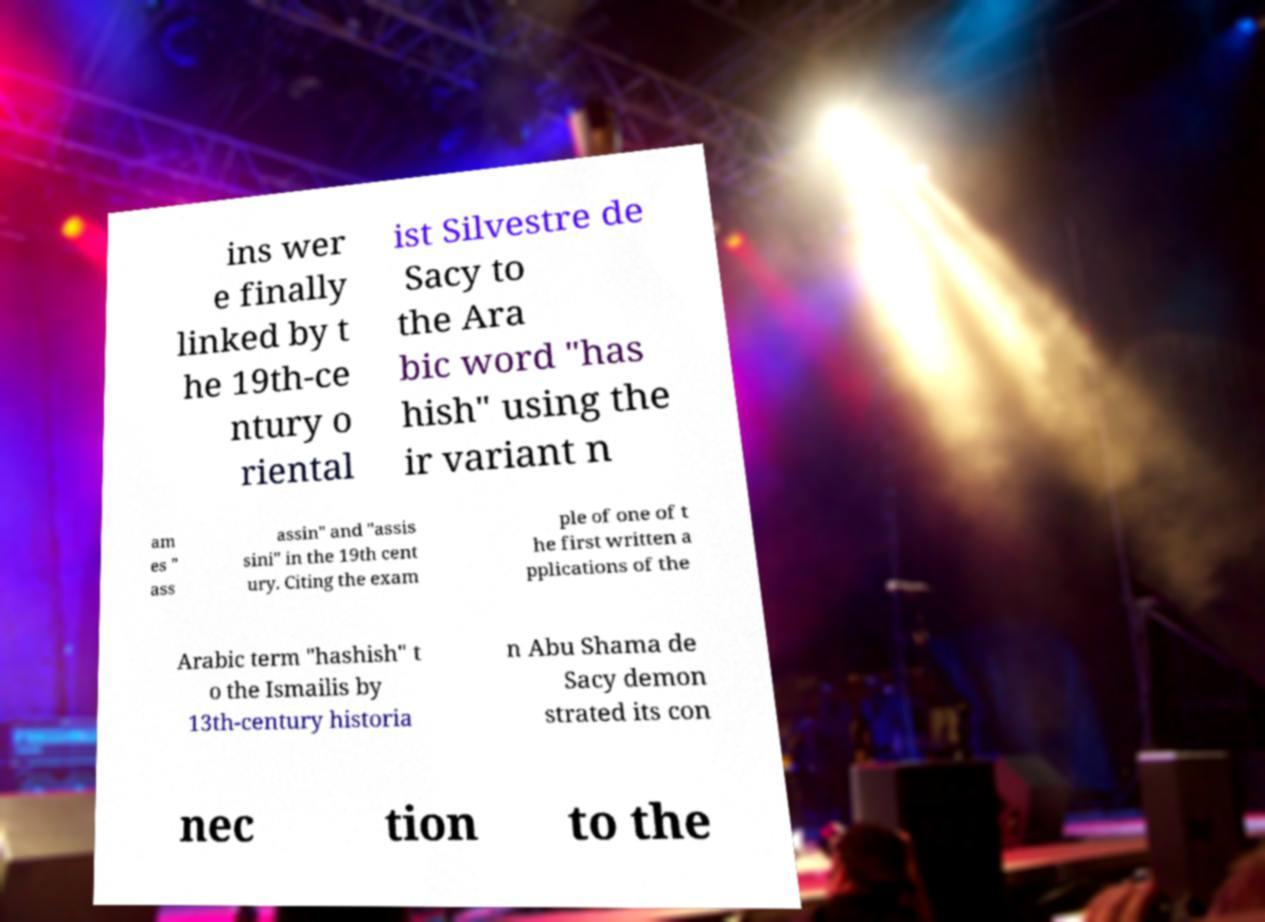Please identify and transcribe the text found in this image. ins wer e finally linked by t he 19th-ce ntury o riental ist Silvestre de Sacy to the Ara bic word "has hish" using the ir variant n am es " ass assin" and "assis sini" in the 19th cent ury. Citing the exam ple of one of t he first written a pplications of the Arabic term "hashish" t o the Ismailis by 13th-century historia n Abu Shama de Sacy demon strated its con nec tion to the 